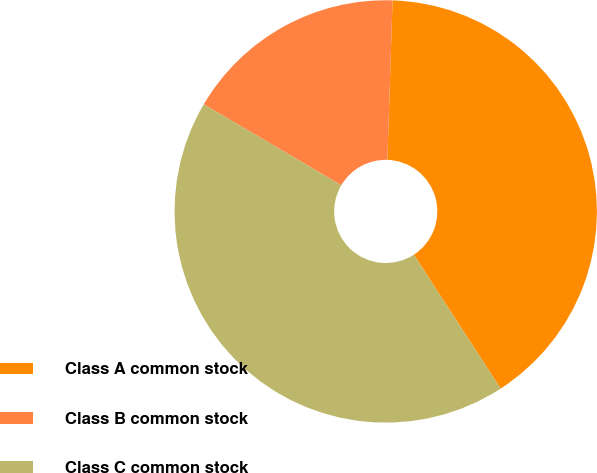Convert chart to OTSL. <chart><loc_0><loc_0><loc_500><loc_500><pie_chart><fcel>Class A common stock<fcel>Class B common stock<fcel>Class C common stock<nl><fcel>40.33%<fcel>17.05%<fcel>42.62%<nl></chart> 